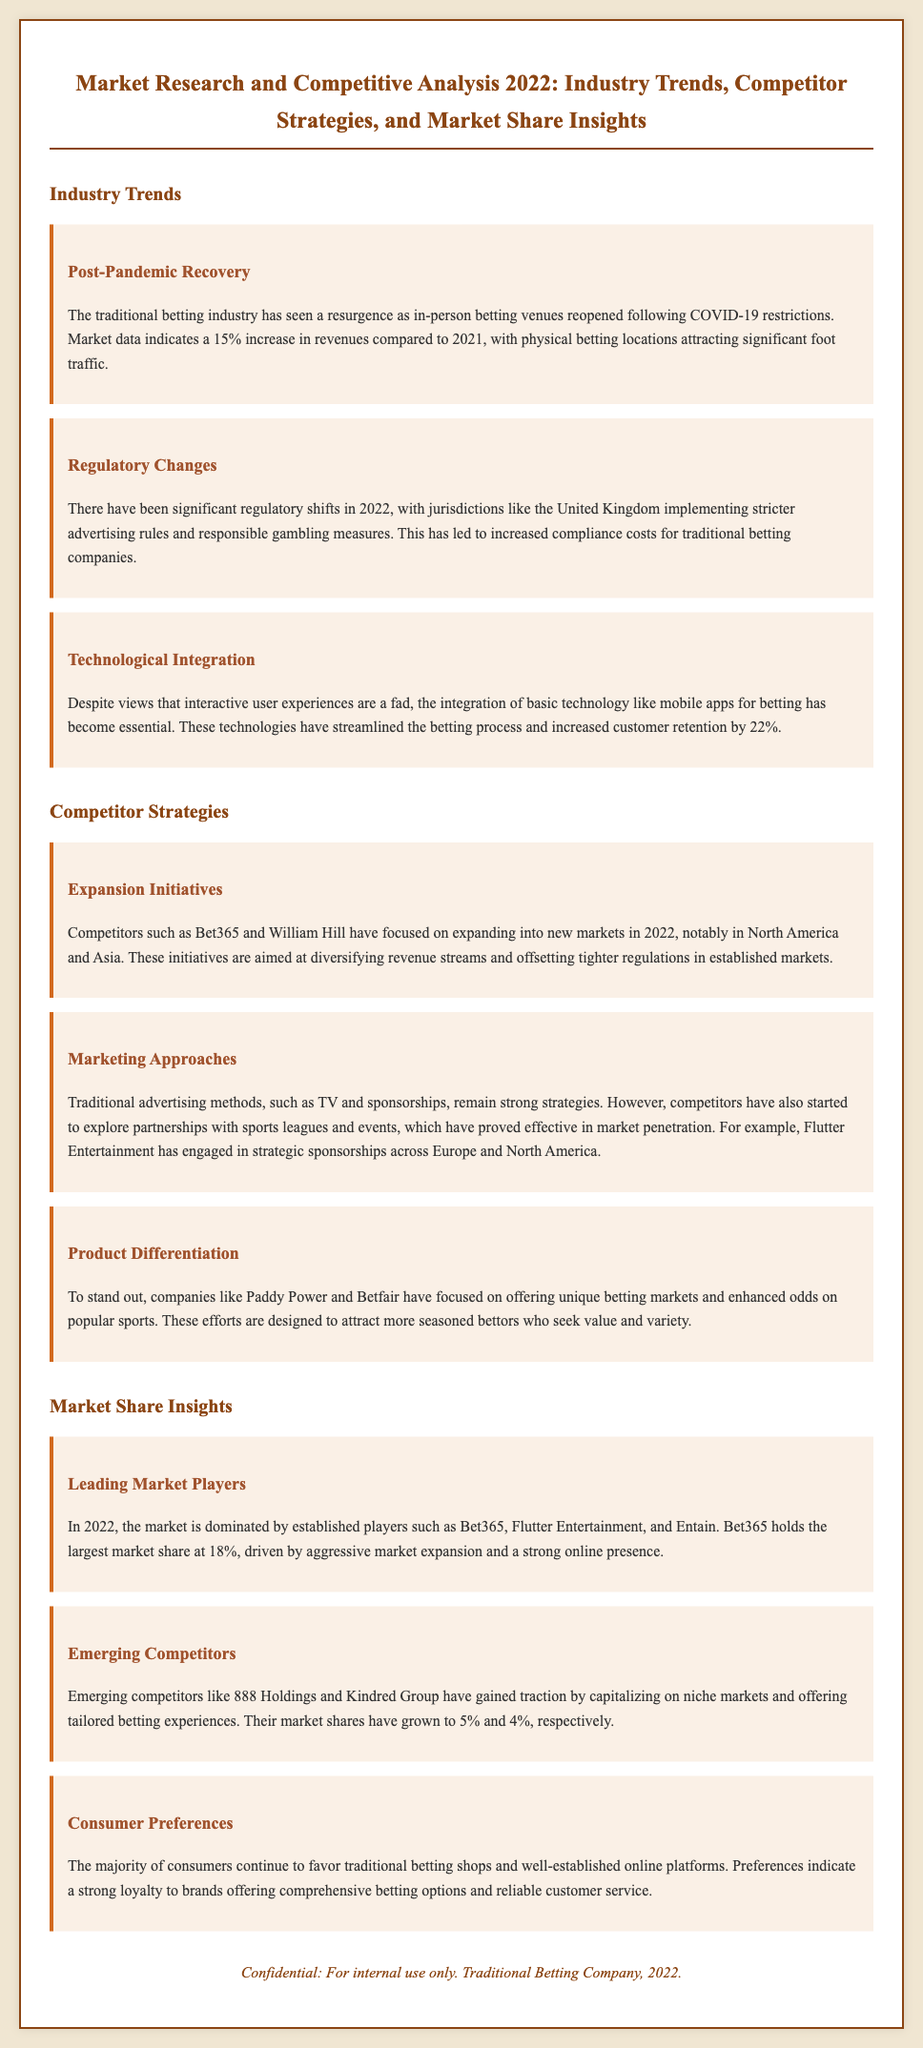What percentage increase in revenues was seen compared to 2021? The document states that there was a 15% increase in revenues in the traditional betting industry compared to 2021.
Answer: 15% What company holds the largest market share in 2022? According to the document, Bet365 holds the largest market share at 18%.
Answer: Bet365 Which region did competitors like Bet365 and William Hill focus on for expansion? The document mentions that these competitors focused on expanding into new markets, notably in North America and Asia.
Answer: North America and Asia What strategies have competitors explored for marketing? The document highlights that competitors have started to explore partnerships with sports leagues and events.
Answer: Partnerships with sports leagues and events What is the market share of 888 Holdings in 2022? The document states that 888 Holdings has gained a market share of 5%.
Answer: 5% 